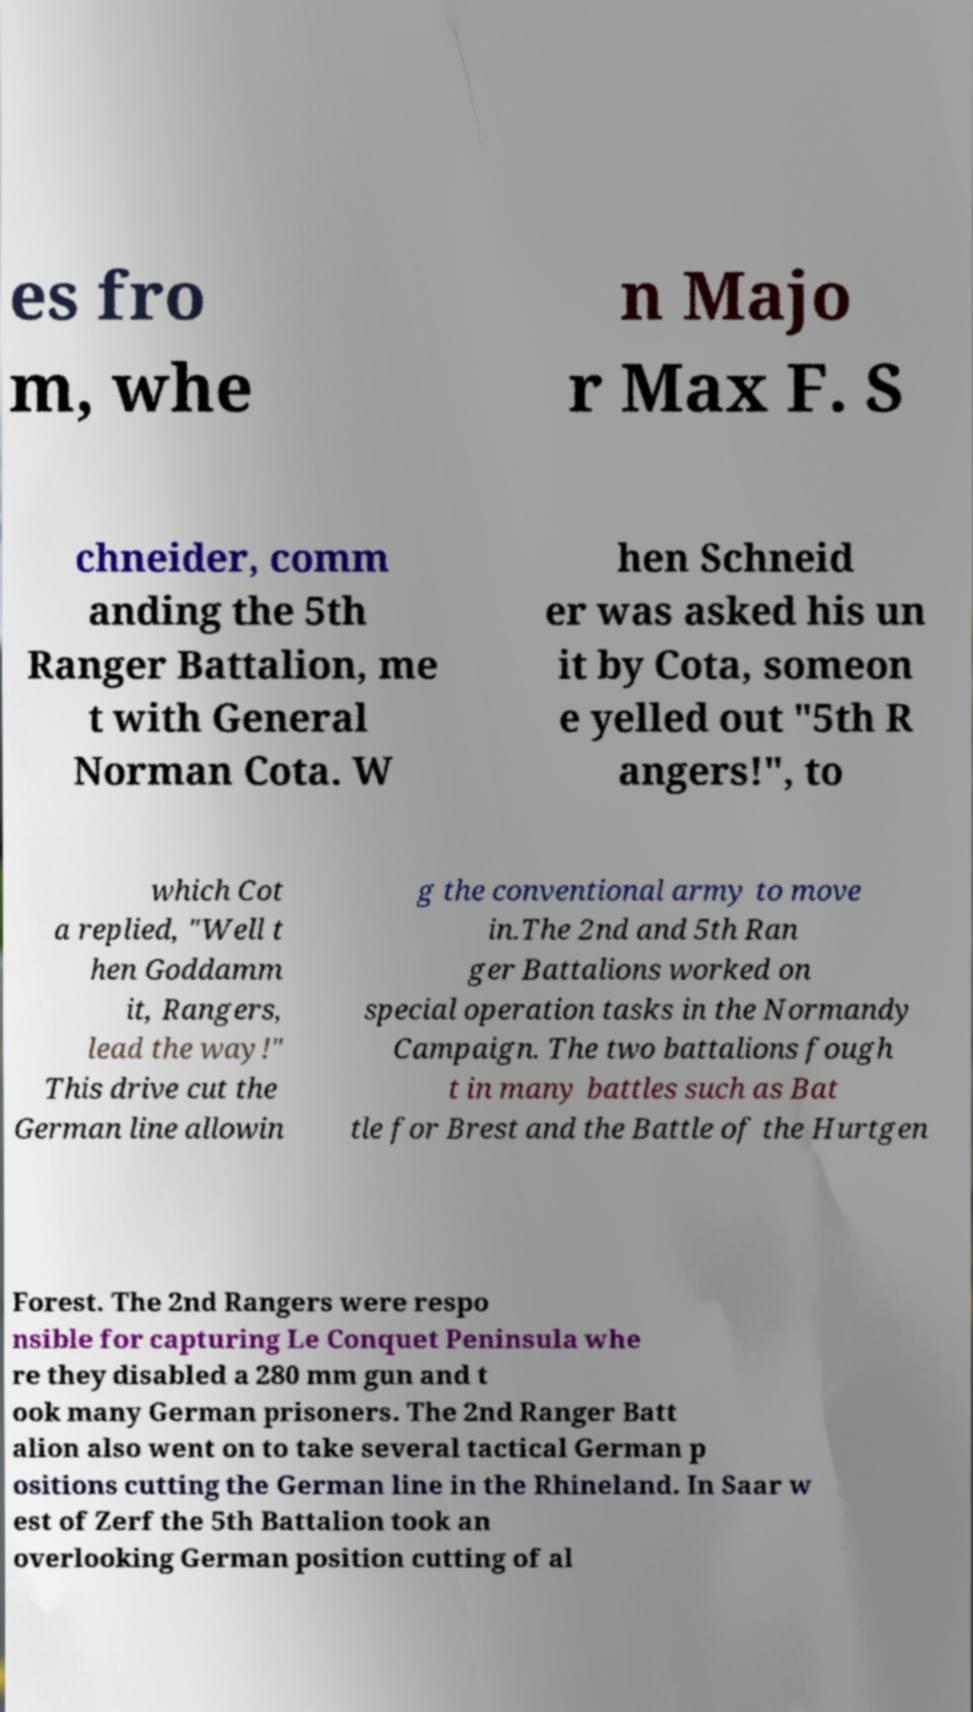Could you assist in decoding the text presented in this image and type it out clearly? es fro m, whe n Majo r Max F. S chneider, comm anding the 5th Ranger Battalion, me t with General Norman Cota. W hen Schneid er was asked his un it by Cota, someon e yelled out "5th R angers!", to which Cot a replied, "Well t hen Goddamm it, Rangers, lead the way!" This drive cut the German line allowin g the conventional army to move in.The 2nd and 5th Ran ger Battalions worked on special operation tasks in the Normandy Campaign. The two battalions fough t in many battles such as Bat tle for Brest and the Battle of the Hurtgen Forest. The 2nd Rangers were respo nsible for capturing Le Conquet Peninsula whe re they disabled a 280 mm gun and t ook many German prisoners. The 2nd Ranger Batt alion also went on to take several tactical German p ositions cutting the German line in the Rhineland. In Saar w est of Zerf the 5th Battalion took an overlooking German position cutting of al 